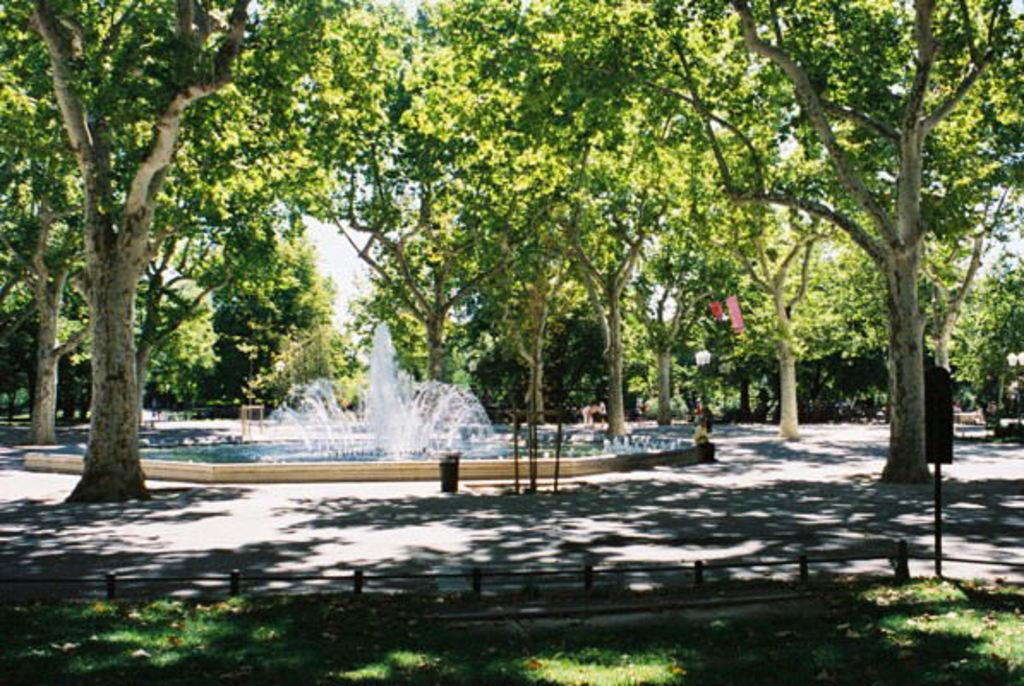What type of vegetation can be seen in the image? There are trees in the image. What is the main feature at the center of the image? There is a fountain at the center of the image. What type of ground cover is present at the bottom of the image? There is grass with fencing at the bottom of the image. How does the beginner navigate the nation in the image? There is no boat, nation, or beginner present in the image; it features trees, a fountain, and grass with fencing. 